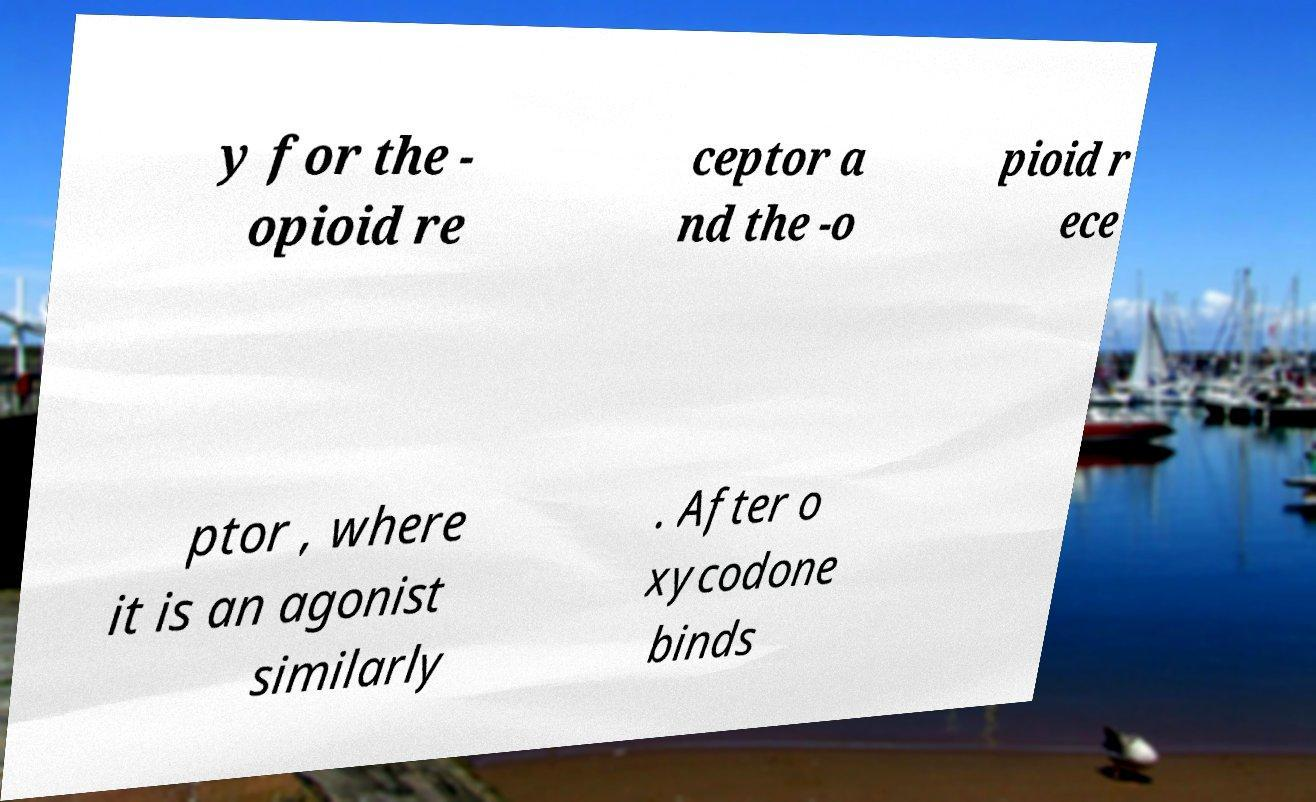I need the written content from this picture converted into text. Can you do that? y for the - opioid re ceptor a nd the -o pioid r ece ptor , where it is an agonist similarly . After o xycodone binds 